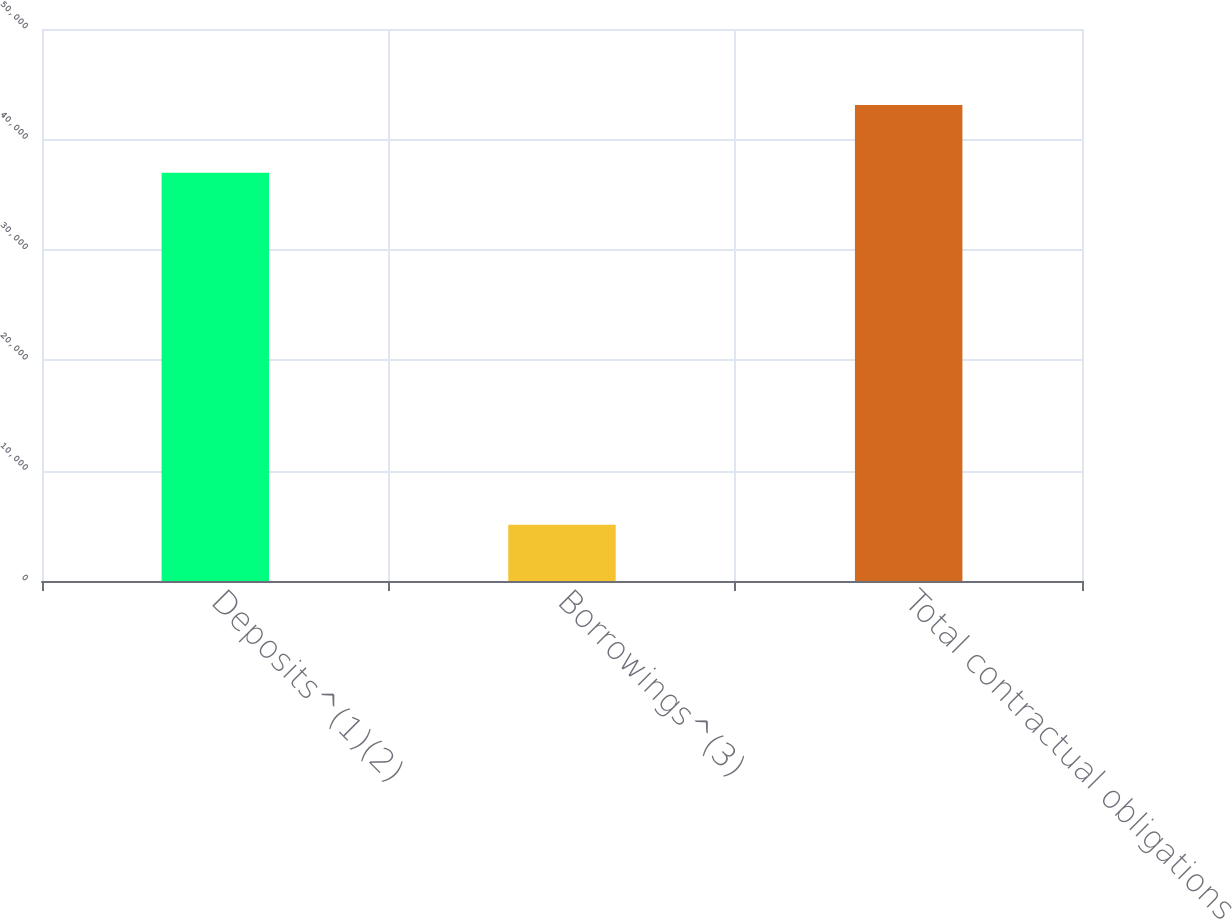Convert chart. <chart><loc_0><loc_0><loc_500><loc_500><bar_chart><fcel>Deposits^(1)(2)<fcel>Borrowings^(3)<fcel>Total contractual obligations<nl><fcel>36984<fcel>5100<fcel>43115<nl></chart> 